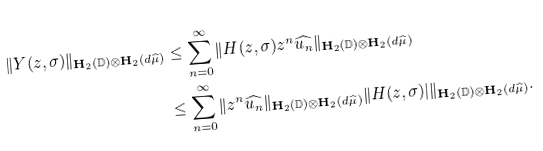<formula> <loc_0><loc_0><loc_500><loc_500>\| Y ( z , \sigma ) \| _ { { \mathbf H } _ { 2 } ( { \mathbb { D } } ) \otimes { \mathbf H } _ { 2 } ( d \widehat { \mu } ) } & \leq \sum _ { n = 0 } ^ { \infty } \| H ( z , \sigma ) z ^ { n } \widehat { u _ { n } } \| _ { { \mathbf H } _ { 2 } ( { \mathbb { D } } ) \otimes { \mathbf H } _ { 2 } ( d \widehat { \mu } ) } \\ & \leq \sum _ { n = 0 } ^ { \infty } \| z ^ { n } \widehat { u _ { n } } \| _ { { \mathbf H } _ { 2 } ( { \mathbb { D } } ) \otimes { \mathbf H } _ { 2 } ( d \widehat { \mu } ) } \| H ( z , \sigma ) | \| _ { { \mathbf H } _ { 2 } ( { \mathbb { D } } ) \otimes { \mathbf H } _ { 2 } ( d \widehat { \mu } ) } .</formula> 